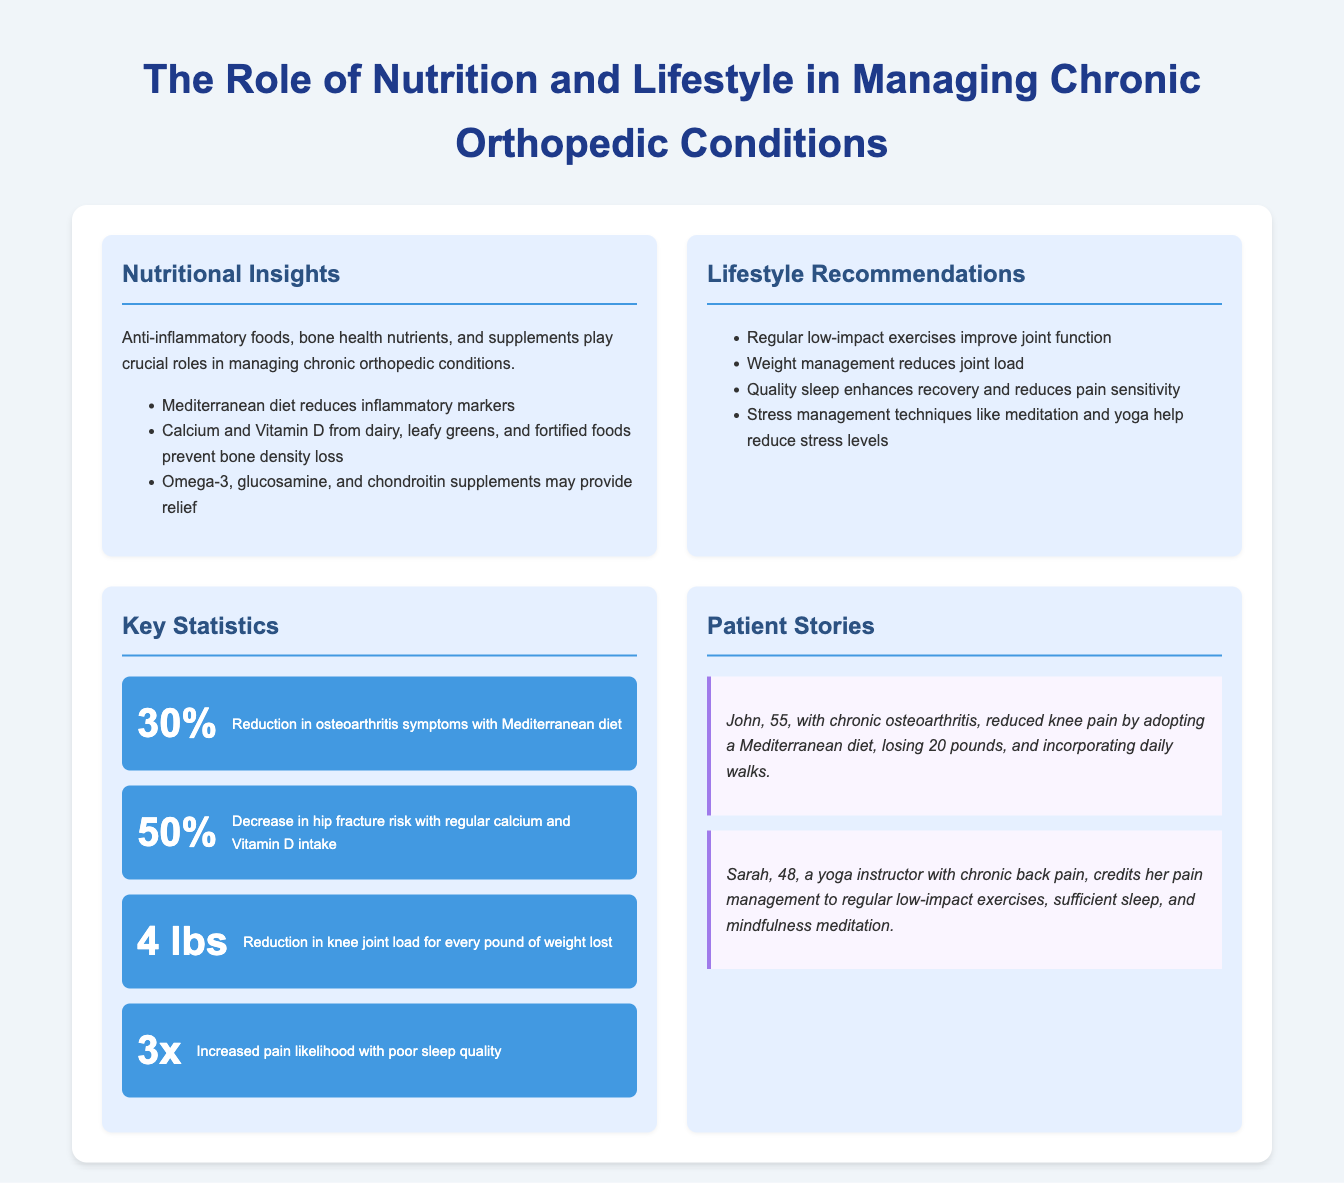What diet is mentioned that reduces inflammatory markers? The document states that the Mediterranean diet reduces inflammatory markers.
Answer: Mediterranean diet What percentage reduction in osteoarthritis symptoms is noted with the Mediterranean diet? According to the infographic, there is a 30% reduction in osteoarthritis symptoms with the Mediterranean diet.
Answer: 30% How much does every pound of weight lost reduce the knee joint load? The document indicates that for every pound of weight lost, there is a reduction of 4 lbs in knee joint load.
Answer: 4 lbs What is the increase in pain likelihood associated with poor sleep quality? The infographic mentions that there is a 3x increased pain likelihood with poor sleep quality.
Answer: 3x Who reduced their knee pain by adopting a Mediterranean diet? John is mentioned as the person who reduced his knee pain by adopting a Mediterranean diet.
Answer: John What is the decrease in hip fracture risk with regular calcium and Vitamin D intake? The document states there is a 50% decrease in hip fracture risk with regular calcium and Vitamin D intake.
Answer: 50% What lifestyle recommendation helps enhance recovery? The document recommends quality sleep to enhance recovery.
Answer: Quality sleep What nutritional component is important for bone density? Calcium and Vitamin D are important for bone density.
Answer: Calcium and Vitamin D What type of exercises are recommended for improving joint function? Regular low-impact exercises are recommended for improving joint function.
Answer: Low-impact exercises 